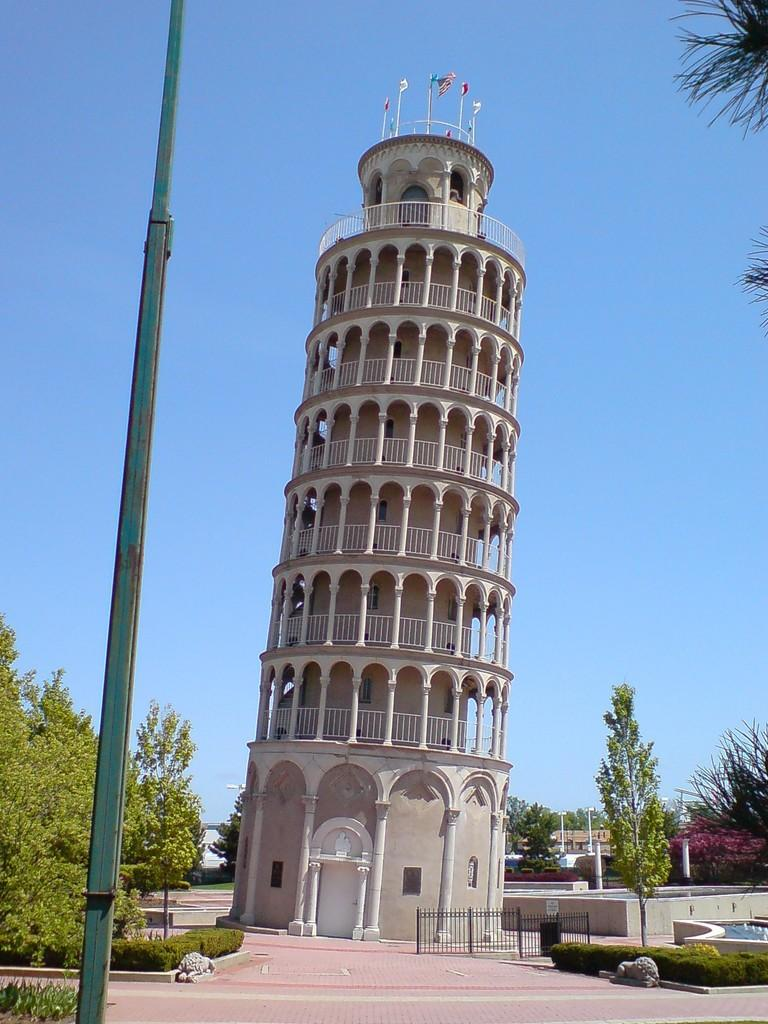What type of structures can be seen in the image? There are buildings in the image. What natural elements are present in the image? There are trees and plants in the image. What type of barrier can be seen in the image? There is a fence in the image. What natural feature is visible in the image? There is water visible in the image. What is visible at the top of the image? The sky is visible at the top of the image. What decorative elements are present in the image? There are flags in the image. What type of silk is draped over the trees in the image? There is no silk present in the image; it features trees, buildings, and other elements mentioned in the facts. What type of wax is used to create the fence in the image? There is no wax mentioned or implied in the image; the fence is described as a barrier without specifying its material. 